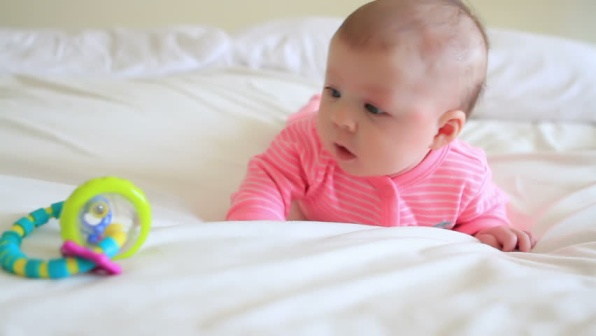Write a short and long description of a possible realistic scenario inspired by the image. Short description: A baby lies on a soft, white bedspread, deeply fascinated by a colorful rattle toy. The baby’s eyes are fixated on the toy, reflecting pure curiosity and wonder. Long description: In a sunlit bedroom bathed in the gentle hues of early morning, a baby lies on a plush, white bedspread. The bedding, slightly wrinkled, adds a touch of homeliness to the serene setting. Dressed in a cozy, striped pink onesie, the baby’s bright eyes are fixated on a vibrant rattle toy placed nearby. The rattle, a cheerful combination of yellow and blue, catches the baby’s attention with its fascinating colors and intriguing design. The baby’s small hand reaches out tentatively towards the toy, fingers wiggling in eager anticipation. This tender moment captures an innocent exploration, a baby’s natural curiosity unfolding in a safe and loving environment. The simplicity of the scene—the soft bedspread, the focused baby, the colorful toy—strikes a perfect balance, celebrating the beauty of everyday life and the joy of discovery. 